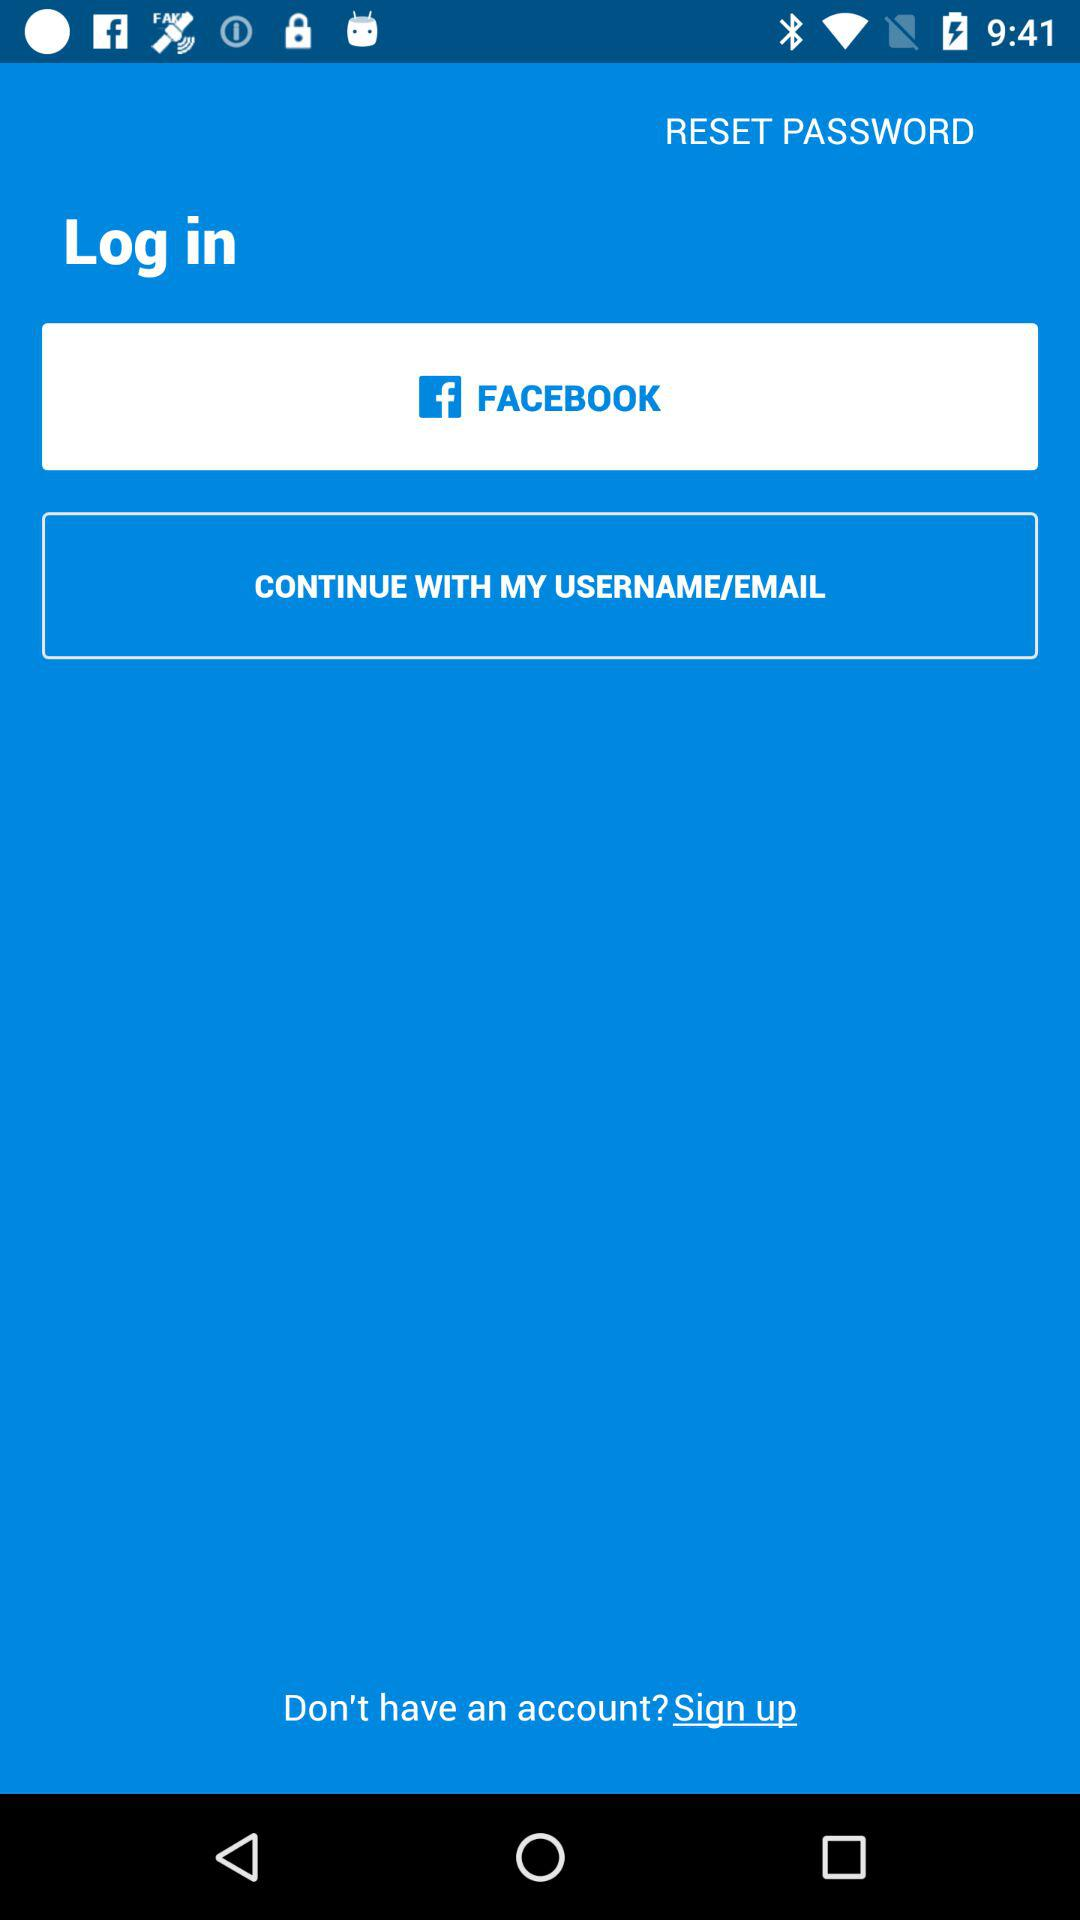By what app can we log in? You can log in with "FACEBOOK". 